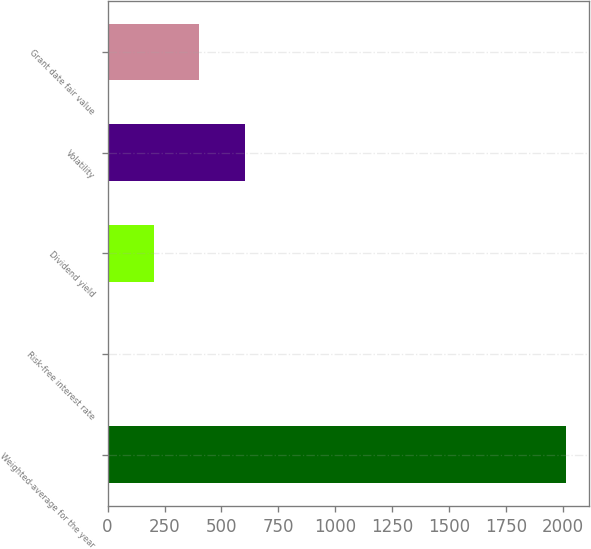Convert chart. <chart><loc_0><loc_0><loc_500><loc_500><bar_chart><fcel>Weighted-average for the year<fcel>Risk-free interest rate<fcel>Dividend yield<fcel>Volatility<fcel>Grant date fair value<nl><fcel>2013<fcel>0.9<fcel>202.11<fcel>604.53<fcel>403.32<nl></chart> 